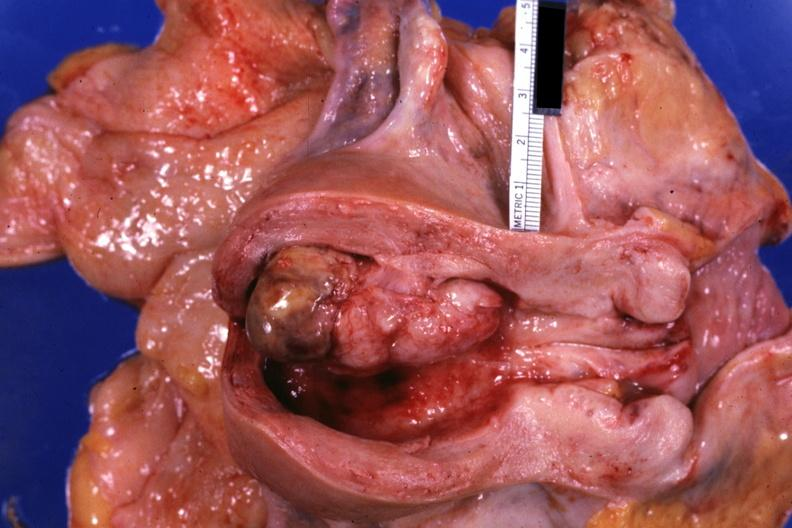does this image show opened uterus with polypoid lesion?
Answer the question using a single word or phrase. Yes 